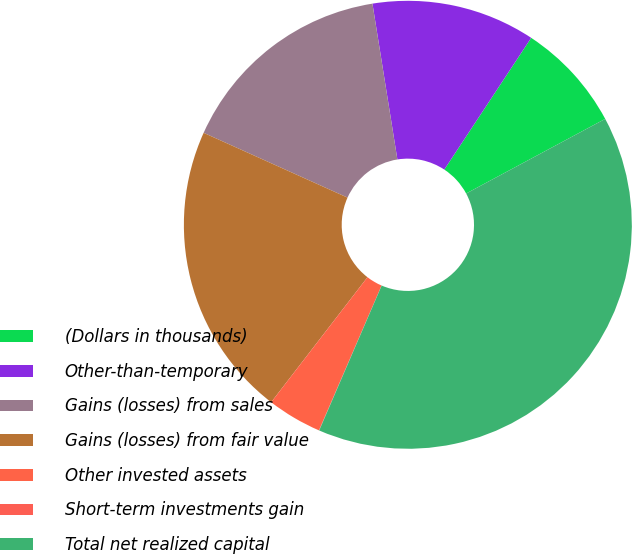Convert chart to OTSL. <chart><loc_0><loc_0><loc_500><loc_500><pie_chart><fcel>(Dollars in thousands)<fcel>Other-than-temporary<fcel>Gains (losses) from sales<fcel>Gains (losses) from fair value<fcel>Other invested assets<fcel>Short-term investments gain<fcel>Total net realized capital<nl><fcel>7.88%<fcel>11.81%<fcel>15.74%<fcel>21.29%<fcel>3.95%<fcel>0.02%<fcel>39.32%<nl></chart> 